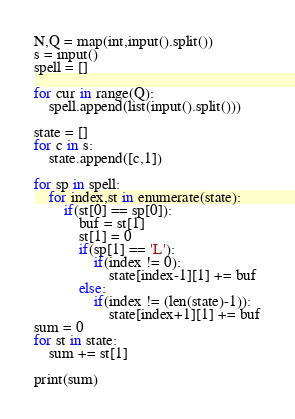Convert code to text. <code><loc_0><loc_0><loc_500><loc_500><_Python_>N,Q = map(int,input().split())
s = input()
spell = []

for cur in range(Q):
	spell.append(list(input().split()))

state = []
for c in s:
	state.append([c,1])

for sp in spell:
	for index,st in enumerate(state):
		if(st[0] == sp[0]):
			buf = st[1]
			st[1] = 0
			if(sp[1] == 'L'):
				if(index != 0):
					state[index-1][1] += buf
			else:
				if(index != (len(state)-1)):
					state[index+1][1] += buf
sum = 0
for st in state:
	sum += st[1]

print(sum)

</code> 